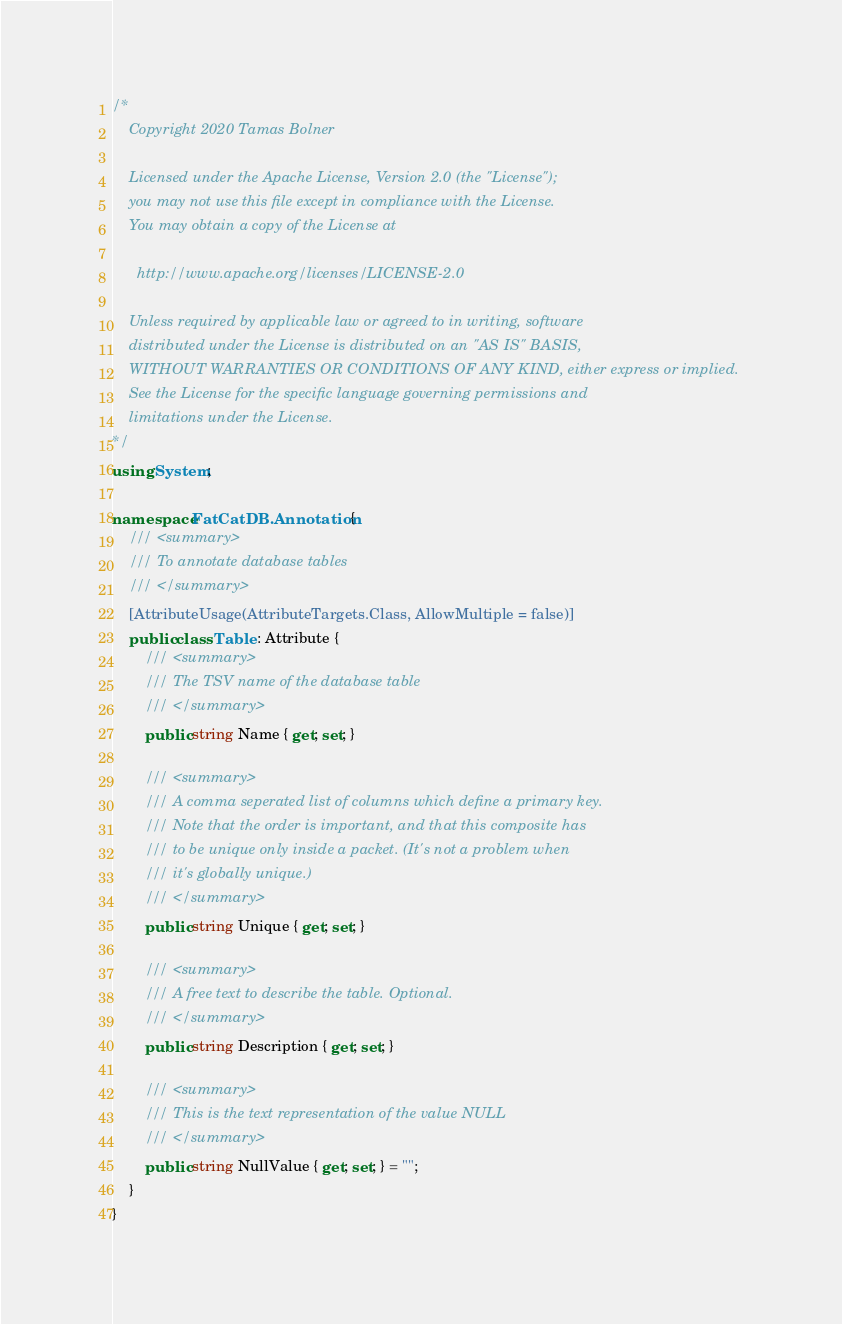Convert code to text. <code><loc_0><loc_0><loc_500><loc_500><_C#_>/*
    Copyright 2020 Tamas Bolner
    
    Licensed under the Apache License, Version 2.0 (the "License");
    you may not use this file except in compliance with the License.
    You may obtain a copy of the License at
    
      http://www.apache.org/licenses/LICENSE-2.0
    
    Unless required by applicable law or agreed to in writing, software
    distributed under the License is distributed on an "AS IS" BASIS,
    WITHOUT WARRANTIES OR CONDITIONS OF ANY KIND, either express or implied.
    See the License for the specific language governing permissions and
    limitations under the License.
*/
using System;

namespace FatCatDB.Annotation {
    /// <summary>
    /// To annotate database tables
    /// </summary>
    [AttributeUsage(AttributeTargets.Class, AllowMultiple = false)]
    public class Table : Attribute {
        /// <summary>
        /// The TSV name of the database table
        /// </summary>
        public string Name { get; set; }

        /// <summary>
        /// A comma seperated list of columns which define a primary key.
        /// Note that the order is important, and that this composite has
        /// to be unique only inside a packet. (It's not a problem when
        /// it's globally unique.)
        /// </summary>
        public string Unique { get; set; }

        /// <summary>
        /// A free text to describe the table. Optional.
        /// </summary>
        public string Description { get; set; }

        /// <summary>
        /// This is the text representation of the value NULL
        /// </summary>
        public string NullValue { get; set; } = "";
    }
}
</code> 